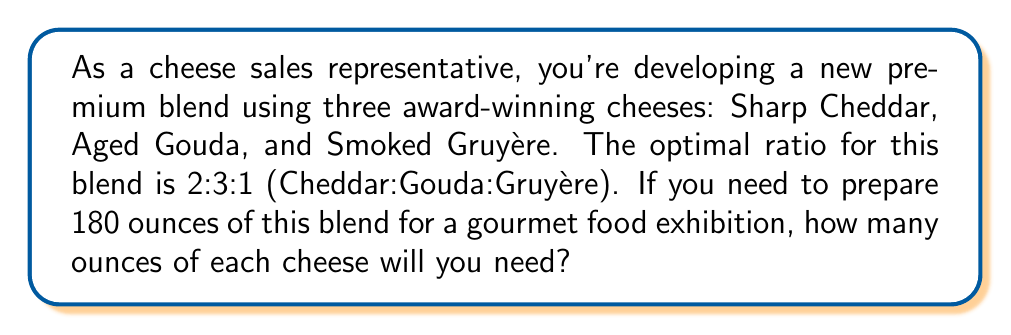Can you answer this question? To solve this problem, we need to follow these steps:

1. Understand the given ratio:
   The ratio of Cheddar:Gouda:Gruyère is 2:3:1

2. Calculate the total parts in the ratio:
   $2 + 3 + 1 = 6$ parts

3. Determine the value of one part:
   Total amount ÷ Total parts = $180 \text{ oz} \div 6 = 30 \text{ oz}$ per part

4. Calculate the amount of each cheese:
   - Sharp Cheddar: $2 \times 30 \text{ oz} = 60 \text{ oz}$
   - Aged Gouda: $3 \times 30 \text{ oz} = 90 \text{ oz}$
   - Smoked Gruyère: $1 \times 30 \text{ oz} = 30 \text{ oz}$

5. Verify the total:
   $60 \text{ oz} + 90 \text{ oz} + 30 \text{ oz} = 180 \text{ oz}$

Therefore, to prepare 180 ounces of the premium blend, you will need 60 ounces of Sharp Cheddar, 90 ounces of Aged Gouda, and 30 ounces of Smoked Gruyère.
Answer: Sharp Cheddar: 60 oz
Aged Gouda: 90 oz
Smoked Gruyère: 30 oz 